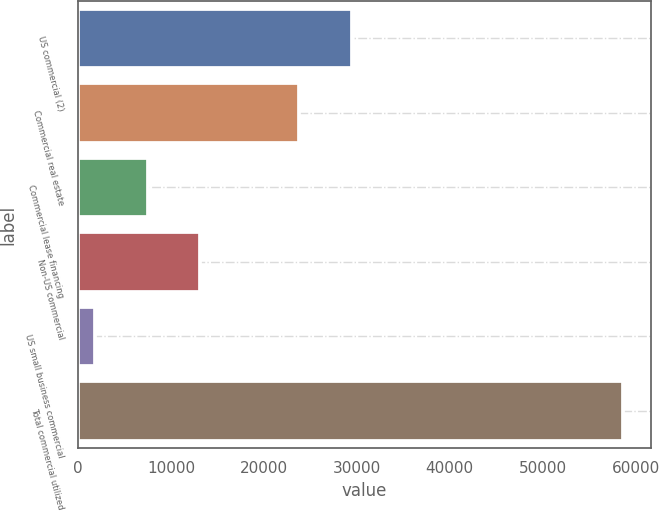Convert chart to OTSL. <chart><loc_0><loc_0><loc_500><loc_500><bar_chart><fcel>US commercial (2)<fcel>Commercial real estate<fcel>Commercial lease financing<fcel>Non-US commercial<fcel>US small business commercial<fcel>Total commercial utilized<nl><fcel>29493.7<fcel>23804<fcel>7478.7<fcel>13168.4<fcel>1789<fcel>58686<nl></chart> 